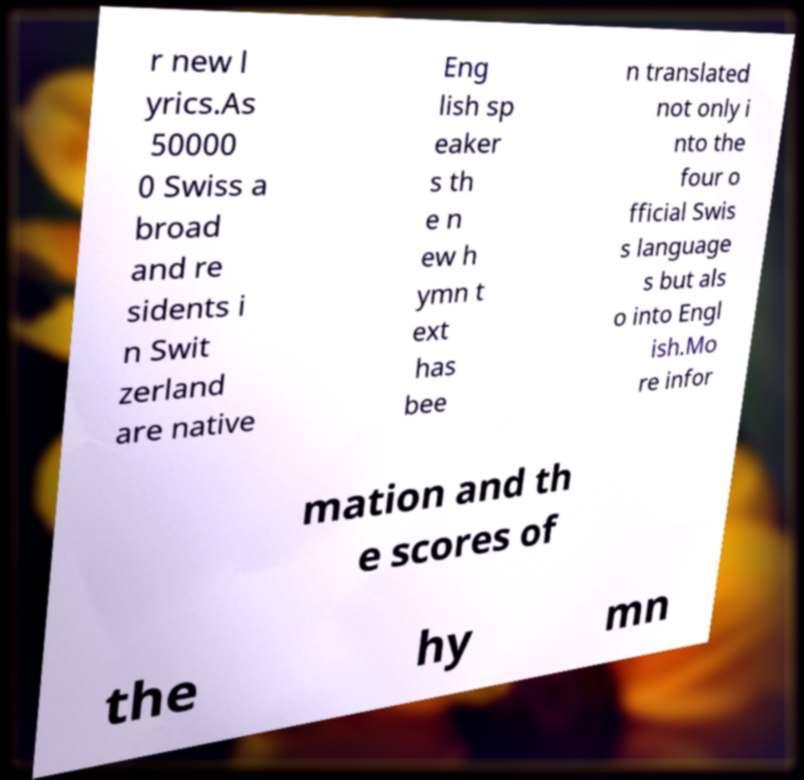For documentation purposes, I need the text within this image transcribed. Could you provide that? r new l yrics.As 50000 0 Swiss a broad and re sidents i n Swit zerland are native Eng lish sp eaker s th e n ew h ymn t ext has bee n translated not only i nto the four o fficial Swis s language s but als o into Engl ish.Mo re infor mation and th e scores of the hy mn 